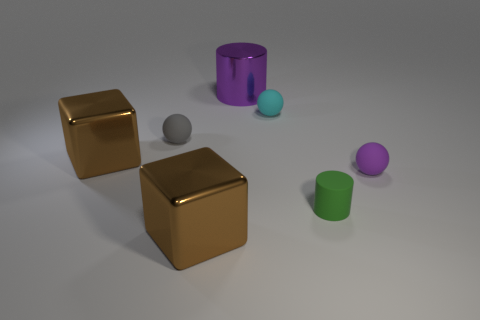Add 2 large metal objects. How many objects exist? 9 Subtract all balls. How many objects are left? 4 Subtract all cyan rubber spheres. Subtract all large shiny things. How many objects are left? 3 Add 3 tiny objects. How many tiny objects are left? 7 Add 7 big purple shiny cylinders. How many big purple shiny cylinders exist? 8 Subtract 0 purple blocks. How many objects are left? 7 